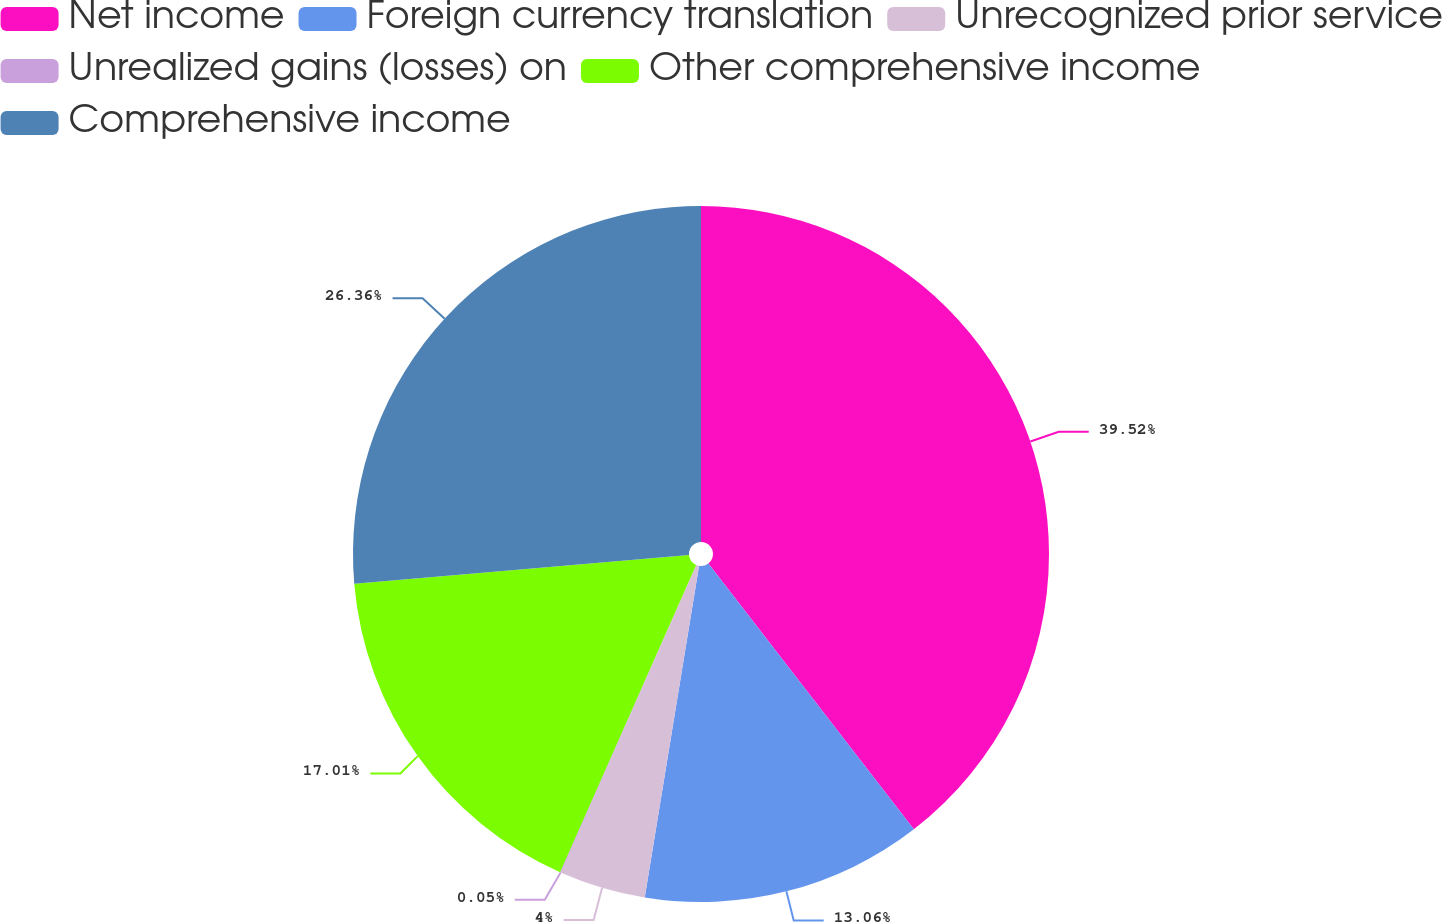Convert chart to OTSL. <chart><loc_0><loc_0><loc_500><loc_500><pie_chart><fcel>Net income<fcel>Foreign currency translation<fcel>Unrecognized prior service<fcel>Unrealized gains (losses) on<fcel>Other comprehensive income<fcel>Comprehensive income<nl><fcel>39.53%<fcel>13.06%<fcel>4.0%<fcel>0.05%<fcel>17.01%<fcel>26.36%<nl></chart> 